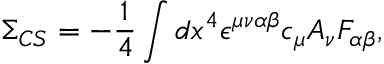Convert formula to latex. <formula><loc_0><loc_0><loc_500><loc_500>\Sigma _ { C S } = - \frac { 1 } { 4 } \int d x ^ { 4 } \epsilon ^ { \mu \nu \alpha \beta } c _ { \mu } A _ { \nu } F _ { \alpha \beta } ,</formula> 